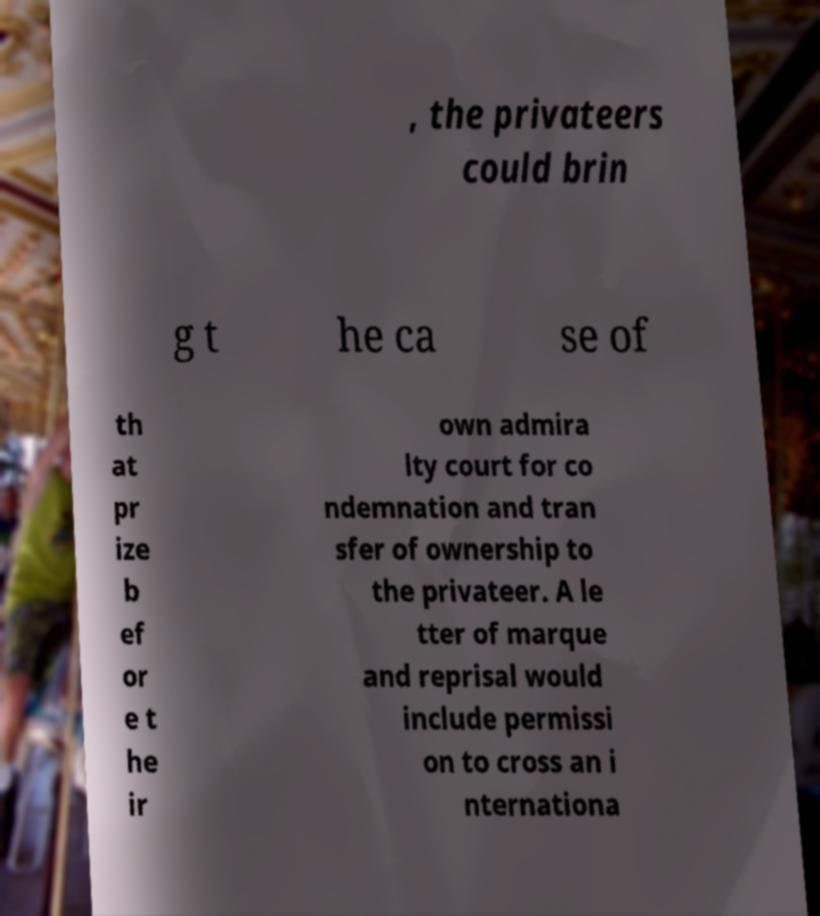There's text embedded in this image that I need extracted. Can you transcribe it verbatim? , the privateers could brin g t he ca se of th at pr ize b ef or e t he ir own admira lty court for co ndemnation and tran sfer of ownership to the privateer. A le tter of marque and reprisal would include permissi on to cross an i nternationa 